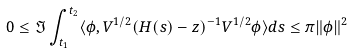<formula> <loc_0><loc_0><loc_500><loc_500>0 \leq \Im \int _ { t _ { 1 } } ^ { t _ { 2 } } \langle \phi , V ^ { 1 / 2 } ( H ( s ) - z ) ^ { - 1 } V ^ { 1 / 2 } \phi \rangle d s \leq \pi \| \phi \| ^ { 2 }</formula> 